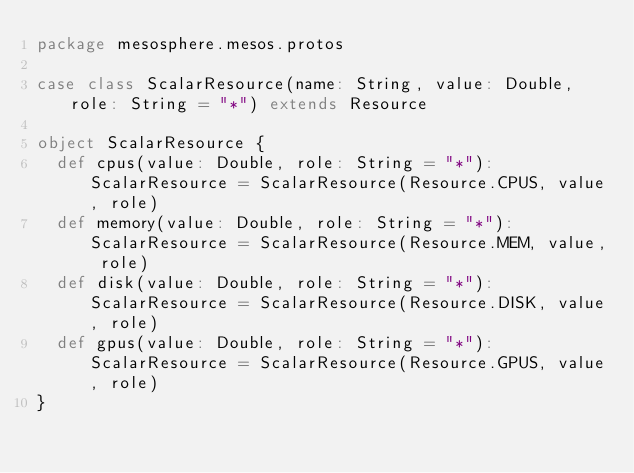<code> <loc_0><loc_0><loc_500><loc_500><_Scala_>package mesosphere.mesos.protos

case class ScalarResource(name: String, value: Double, role: String = "*") extends Resource

object ScalarResource {
  def cpus(value: Double, role: String = "*"): ScalarResource = ScalarResource(Resource.CPUS, value, role)
  def memory(value: Double, role: String = "*"): ScalarResource = ScalarResource(Resource.MEM, value, role)
  def disk(value: Double, role: String = "*"): ScalarResource = ScalarResource(Resource.DISK, value, role)
  def gpus(value: Double, role: String = "*"): ScalarResource = ScalarResource(Resource.GPUS, value, role)
}
</code> 